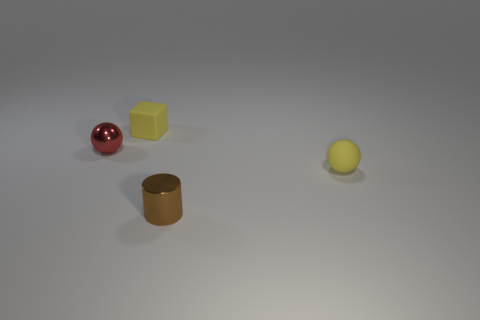Add 1 rubber spheres. How many objects exist? 5 Subtract all blocks. How many objects are left? 3 Subtract all large yellow things. Subtract all tiny yellow matte things. How many objects are left? 2 Add 1 yellow spheres. How many yellow spheres are left? 2 Add 3 blue metal cylinders. How many blue metal cylinders exist? 3 Subtract 0 blue cubes. How many objects are left? 4 